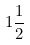Convert formula to latex. <formula><loc_0><loc_0><loc_500><loc_500>1 \frac { 1 } { 2 }</formula> 